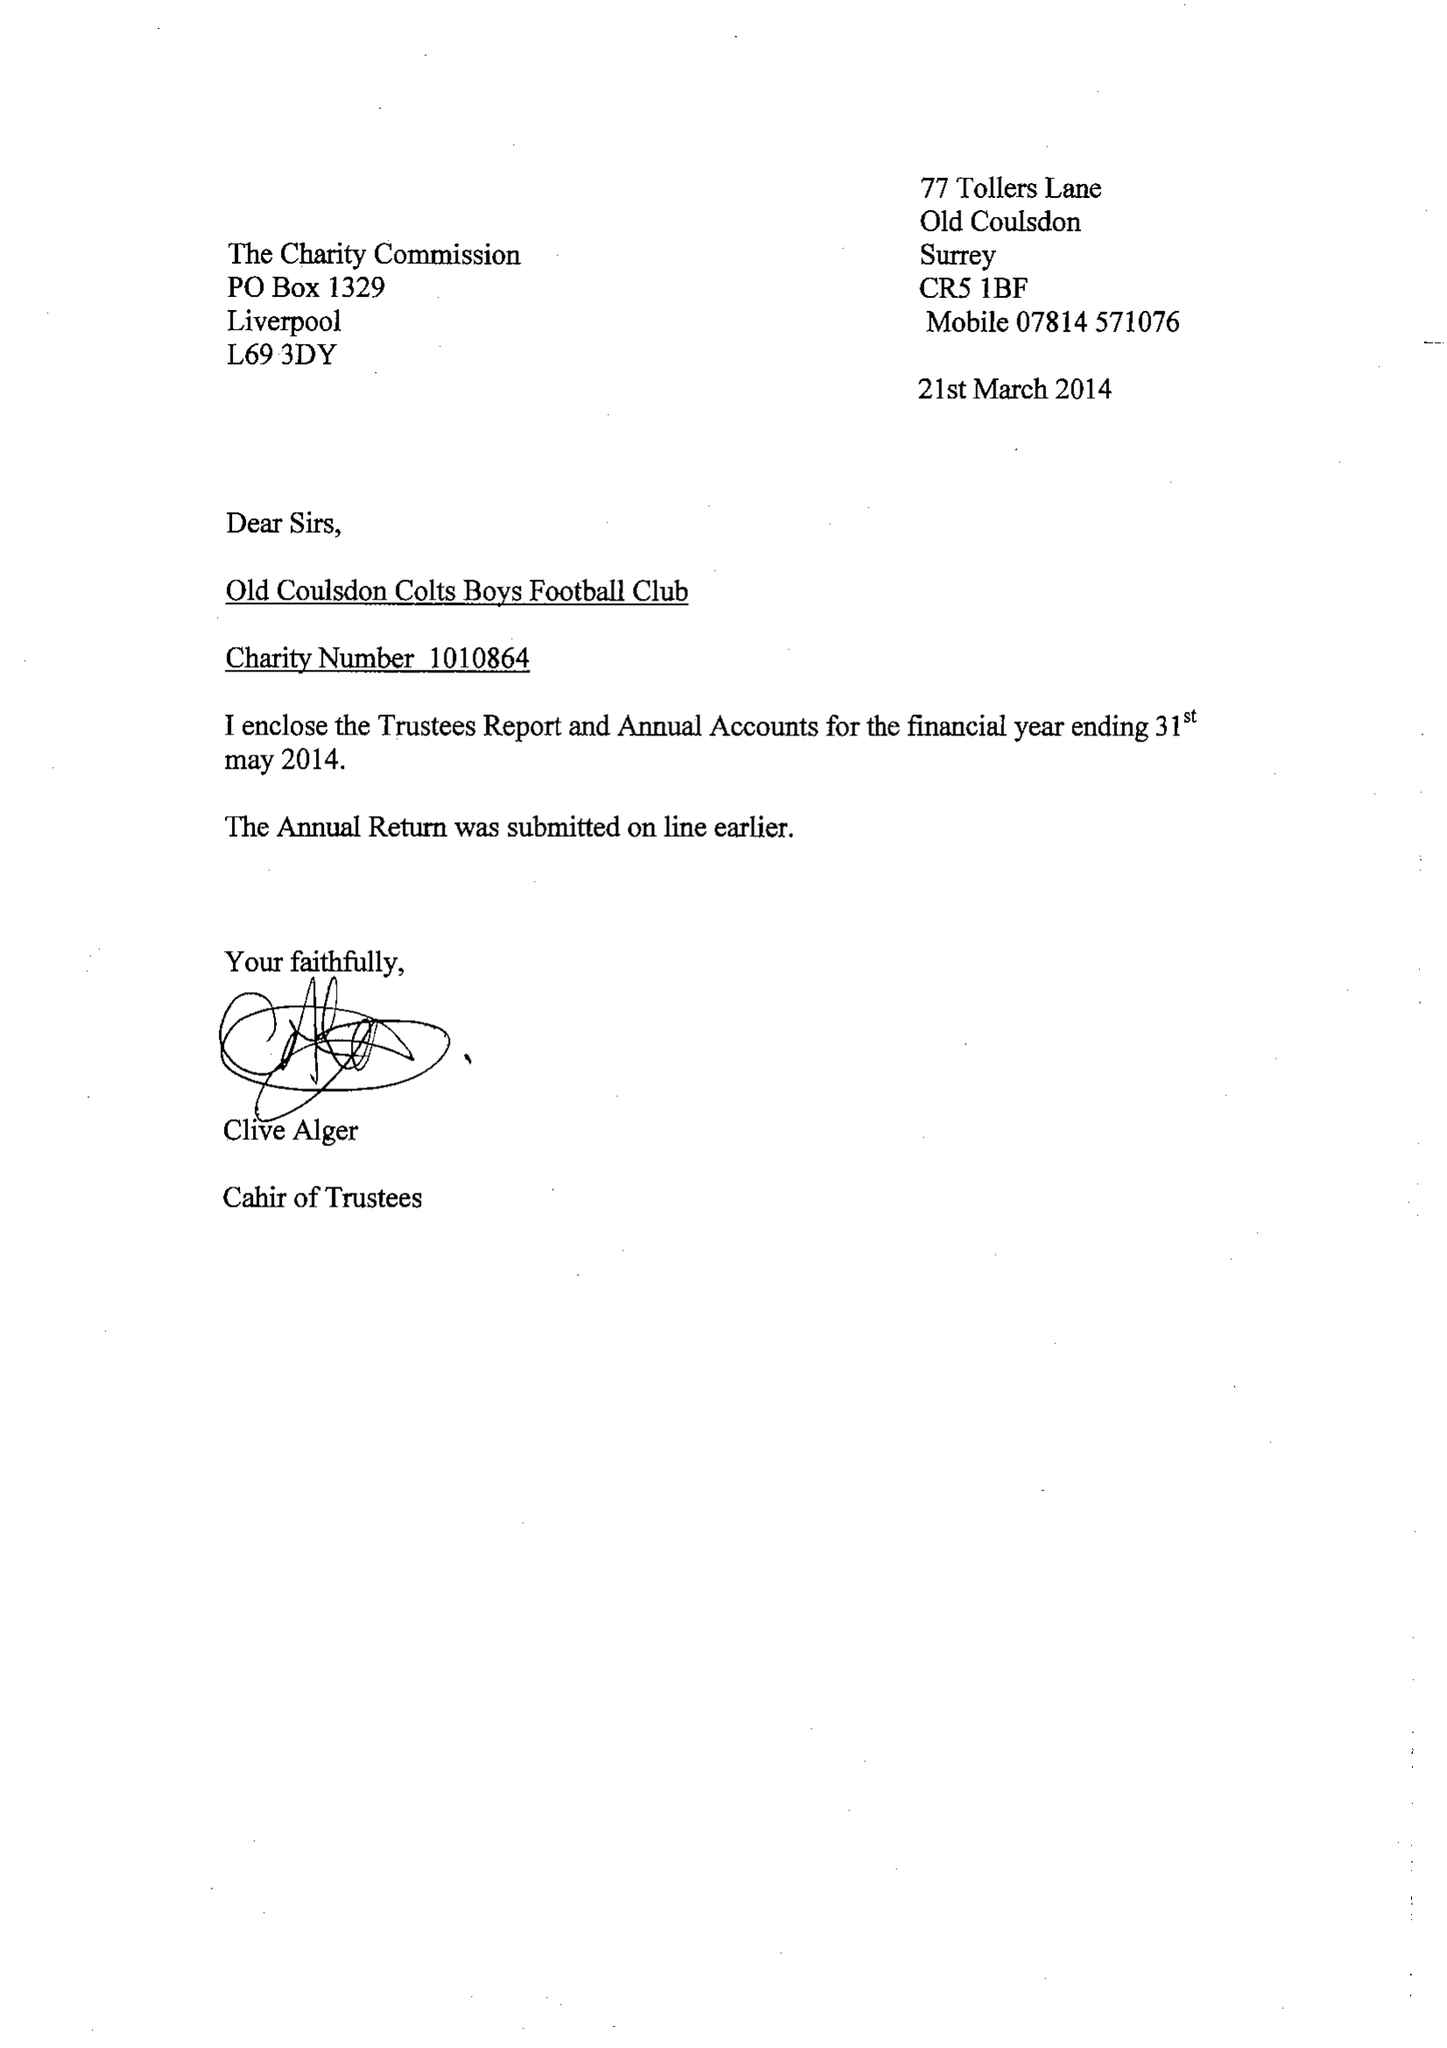What is the value for the charity_number?
Answer the question using a single word or phrase. 1010864 